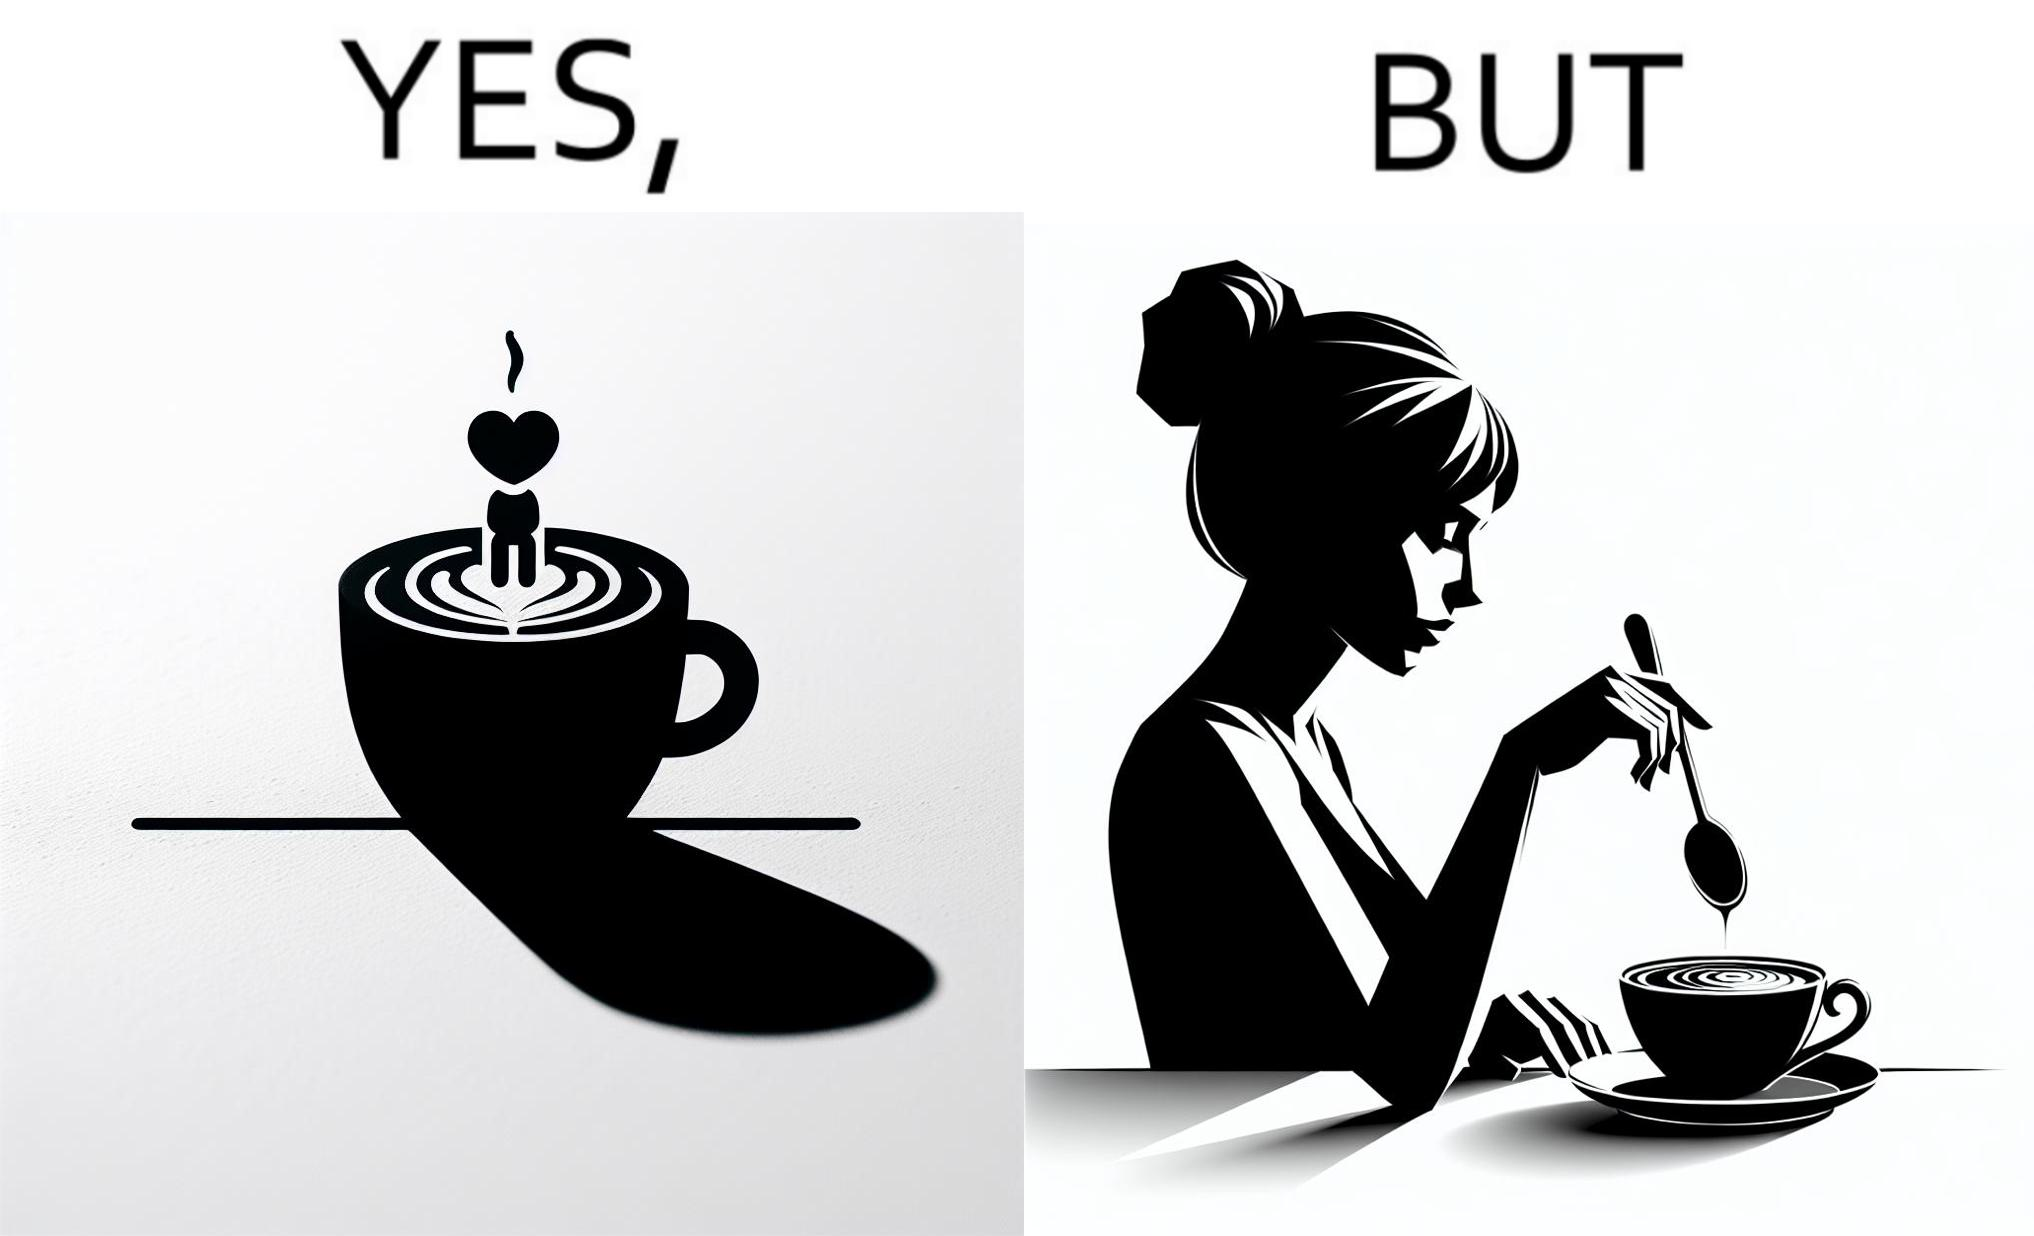What do you see in each half of this image? In the left part of the image: a cup of coffee with latte art on it In the right part of the image: a person stirring the coffee with spoon 